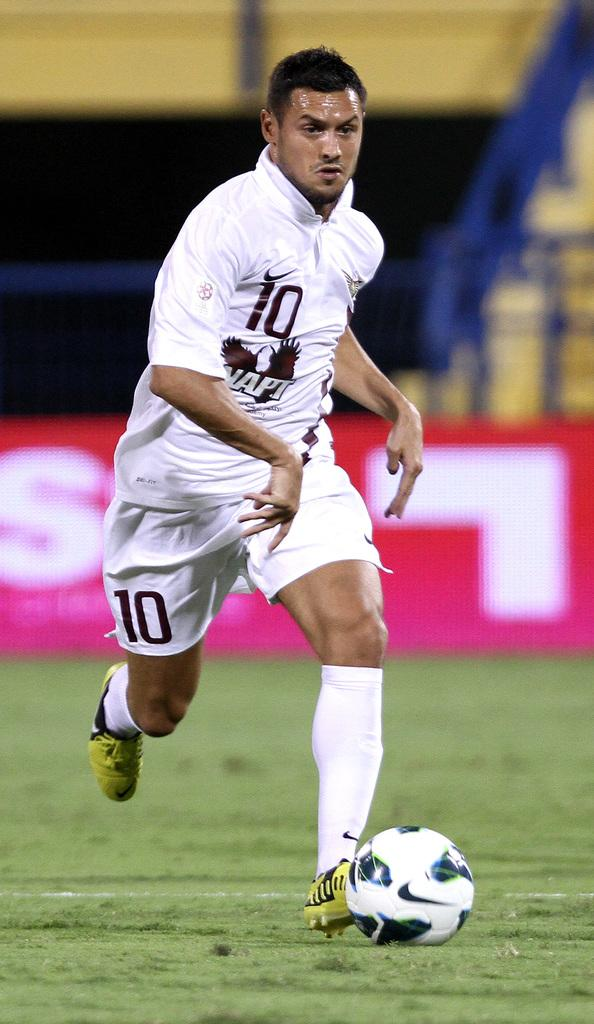<image>
Describe the image concisely. Player number 10 kicks a ball across a field. 